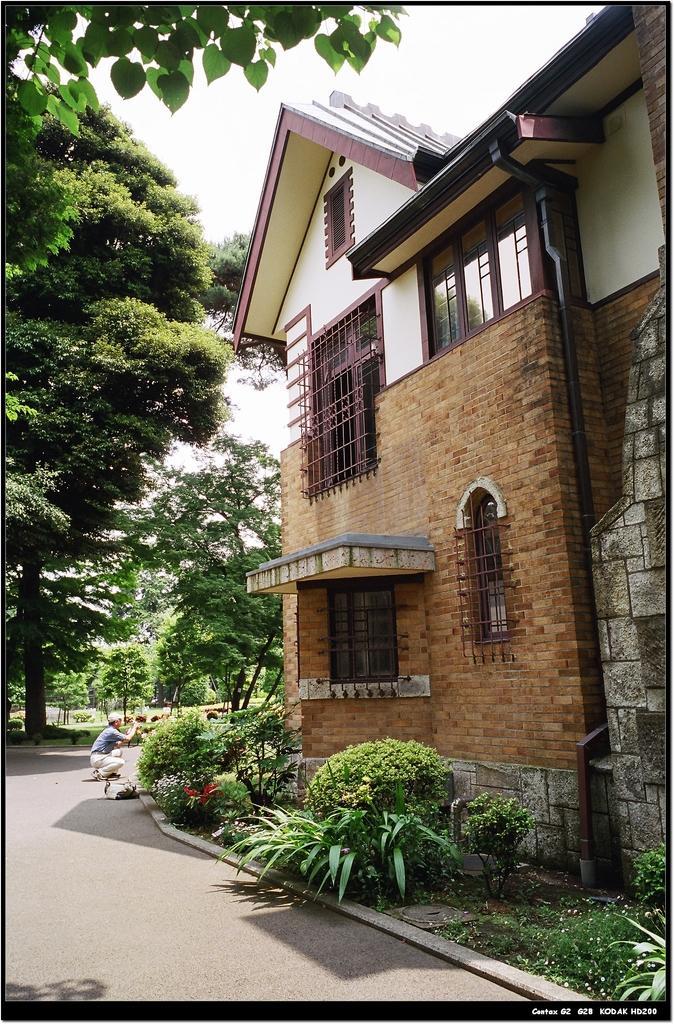In one or two sentences, can you explain what this image depicts? In this image there is a path in the middle. On the right side there is a building with the glass windows. At the bottom there is a garden in which there are plants. On the left side there are trees. In the middle there is a person who is sitting in the squat position. At the top there is the sky. 